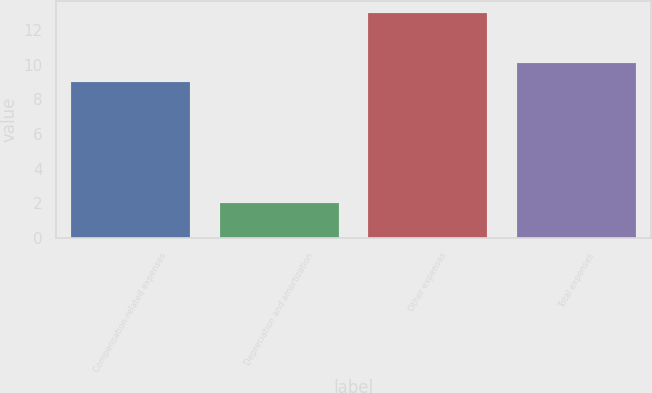Convert chart. <chart><loc_0><loc_0><loc_500><loc_500><bar_chart><fcel>Compensation-related expenses<fcel>Depreciation and amortization<fcel>Other expenses<fcel>Total expenses<nl><fcel>9<fcel>2<fcel>13<fcel>10.1<nl></chart> 